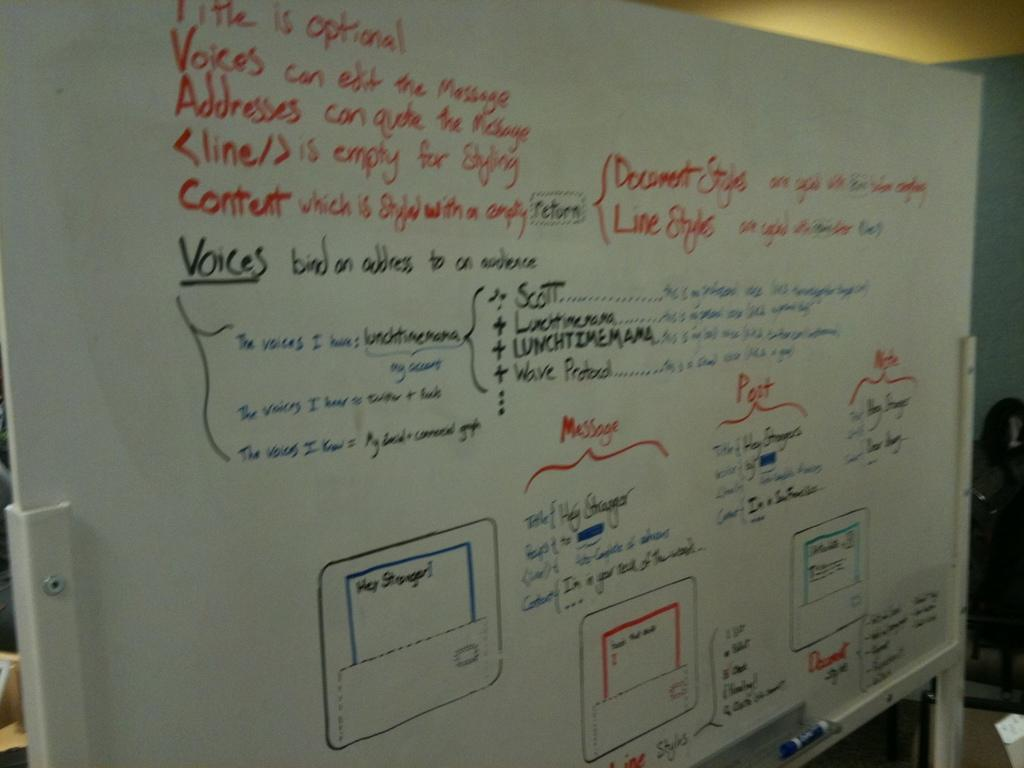<image>
Relay a brief, clear account of the picture shown. a white board with red, black and blue text like Voices on it 